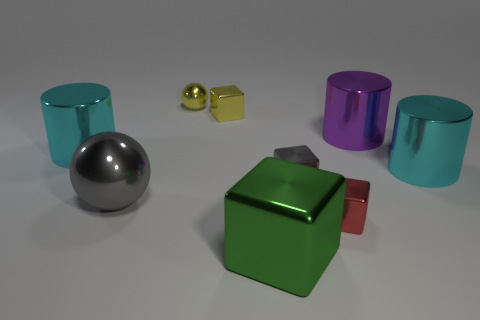Are there more yellow balls left of the gray ball than large purple matte balls?
Ensure brevity in your answer.  No. There is a shiny block that is behind the gray thing on the right side of the yellow metallic block; how many tiny gray blocks are behind it?
Give a very brief answer. 0. What material is the small thing that is behind the large purple shiny thing and to the right of the small yellow sphere?
Offer a very short reply. Metal. What is the color of the large sphere?
Provide a succinct answer. Gray. Are there more small yellow cubes that are right of the big green metallic cube than green things right of the red block?
Offer a very short reply. No. There is a shiny ball that is on the right side of the large gray object; what color is it?
Your answer should be compact. Yellow. Does the cyan object that is left of the red block have the same size as the cyan object that is on the right side of the big gray thing?
Your response must be concise. Yes. What number of things are small cyan shiny objects or large purple shiny objects?
Your answer should be very brief. 1. There is a gray thing that is on the left side of the yellow metallic object that is in front of the tiny yellow ball; what is its material?
Make the answer very short. Metal. How many red things are the same shape as the green metal thing?
Your response must be concise. 1. 